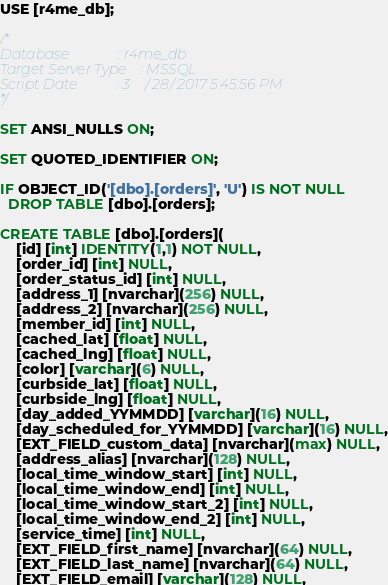<code> <loc_0><loc_0><loc_500><loc_500><_SQL_>USE [r4me_db];

/*
Database              : r4me_db
Target Server Type    : MSSQL
Script Date           : 3/28/2017 5:45:56 PM
*/

SET ANSI_NULLS ON;

SET QUOTED_IDENTIFIER ON;

IF OBJECT_ID('[dbo].[orders]', 'U') IS NOT NULL
  DROP TABLE [dbo].[orders];

CREATE TABLE [dbo].[orders](
	[id] [int] IDENTITY(1,1) NOT NULL,
	[order_id] [int] NULL,
	[order_status_id] [int] NULL,
	[address_1] [nvarchar](256) NULL,
	[address_2] [nvarchar](256) NULL,
	[member_id] [int] NULL,
	[cached_lat] [float] NULL,
	[cached_lng] [float] NULL,
	[color] [varchar](6) NULL,
	[curbside_lat] [float] NULL,
	[curbside_lng] [float] NULL,
	[day_added_YYMMDD] [varchar](16) NULL,
	[day_scheduled_for_YYMMDD] [varchar](16) NULL,
	[EXT_FIELD_custom_data] [nvarchar](max) NULL,
	[address_alias] [nvarchar](128) NULL,
	[local_time_window_start] [int] NULL,
	[local_time_window_end] [int] NULL,
	[local_time_window_start_2] [int] NULL,
	[local_time_window_end_2] [int] NULL,
	[service_time] [int] NULL,
	[EXT_FIELD_first_name] [nvarchar](64) NULL,
	[EXT_FIELD_last_name] [nvarchar](64) NULL,
	[EXT_FIELD_email] [varchar](128) NULL,</code> 